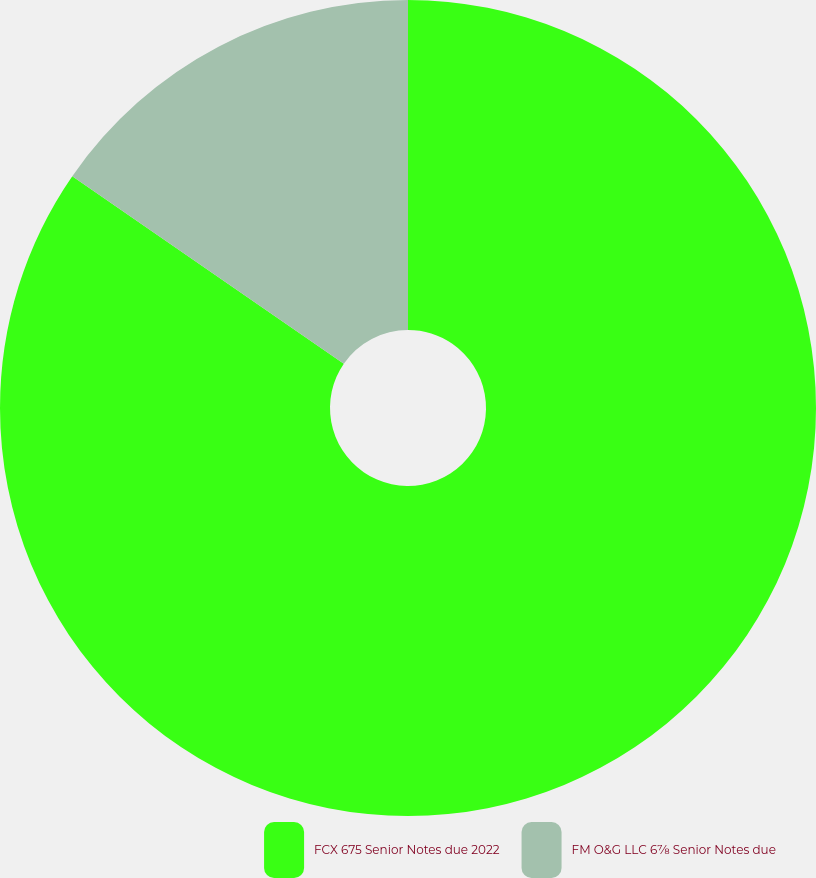Convert chart. <chart><loc_0><loc_0><loc_500><loc_500><pie_chart><fcel>FCX 675 Senior Notes due 2022<fcel>FM O&G LLC 6⅞ Senior Notes due<nl><fcel>84.62%<fcel>15.38%<nl></chart> 